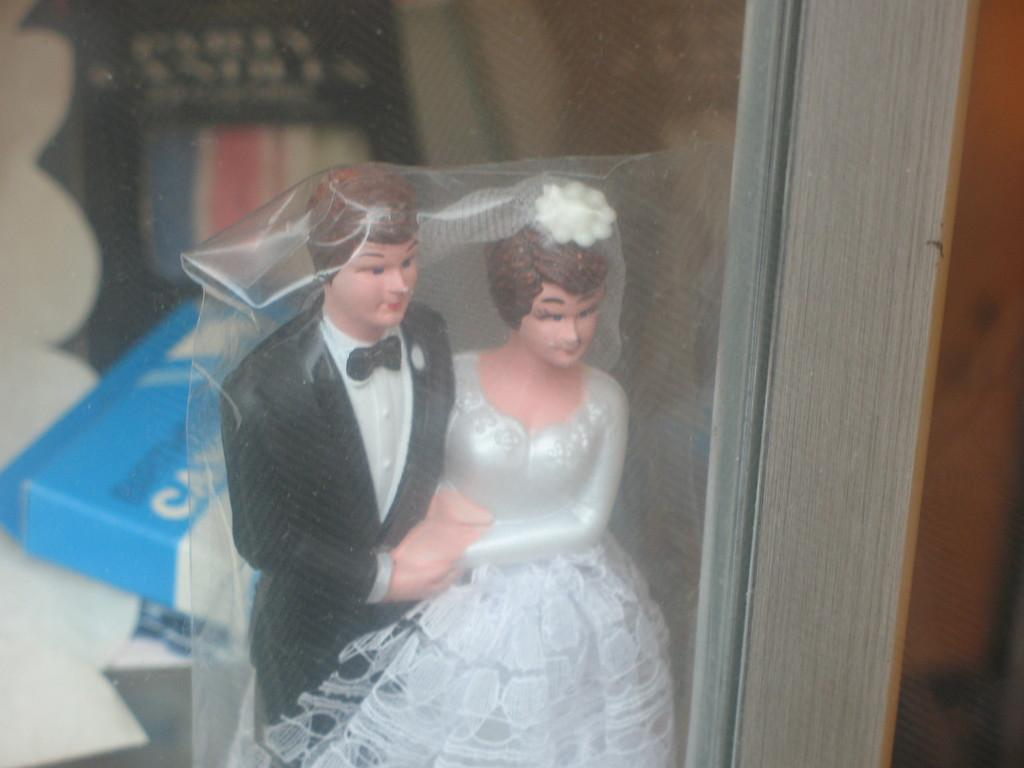What is the main object in the image? There is a toy in the image. How is the toy protected or covered? The toy is covered with a plastic cover. What is the color of the surface where the objects are placed? The objects are on a white surface in the image. What is the color and location of the object on the right side of the image? There is a brown object on the right side of the image. What type of creature is performing in the band in the image? There is no band or creature present in the image. What kind of feast is being prepared on the white surface in the image? There is no feast being prepared in the image; it only shows objects on a white surface. 